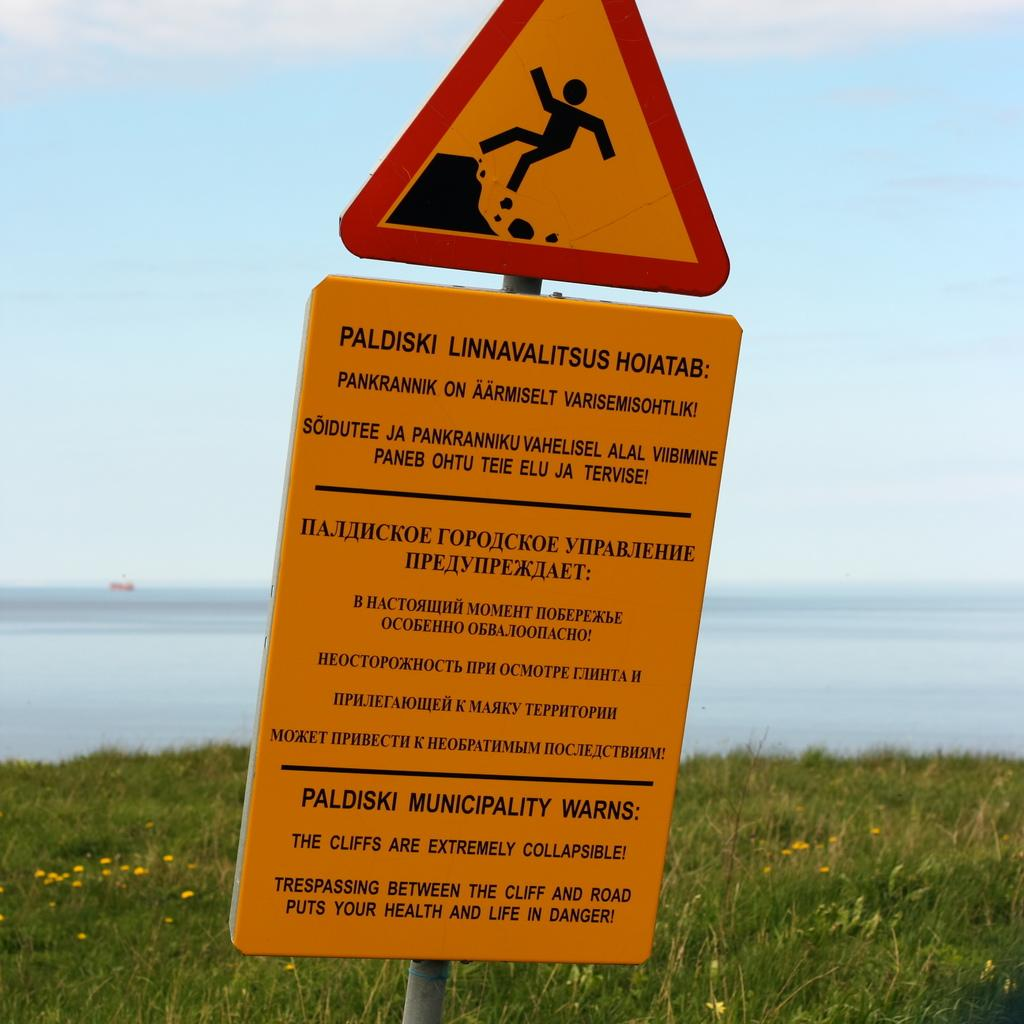<image>
Render a clear and concise summary of the photo. A sign warning of cliffs that are vulnerable to collapsing in Paldiski. 